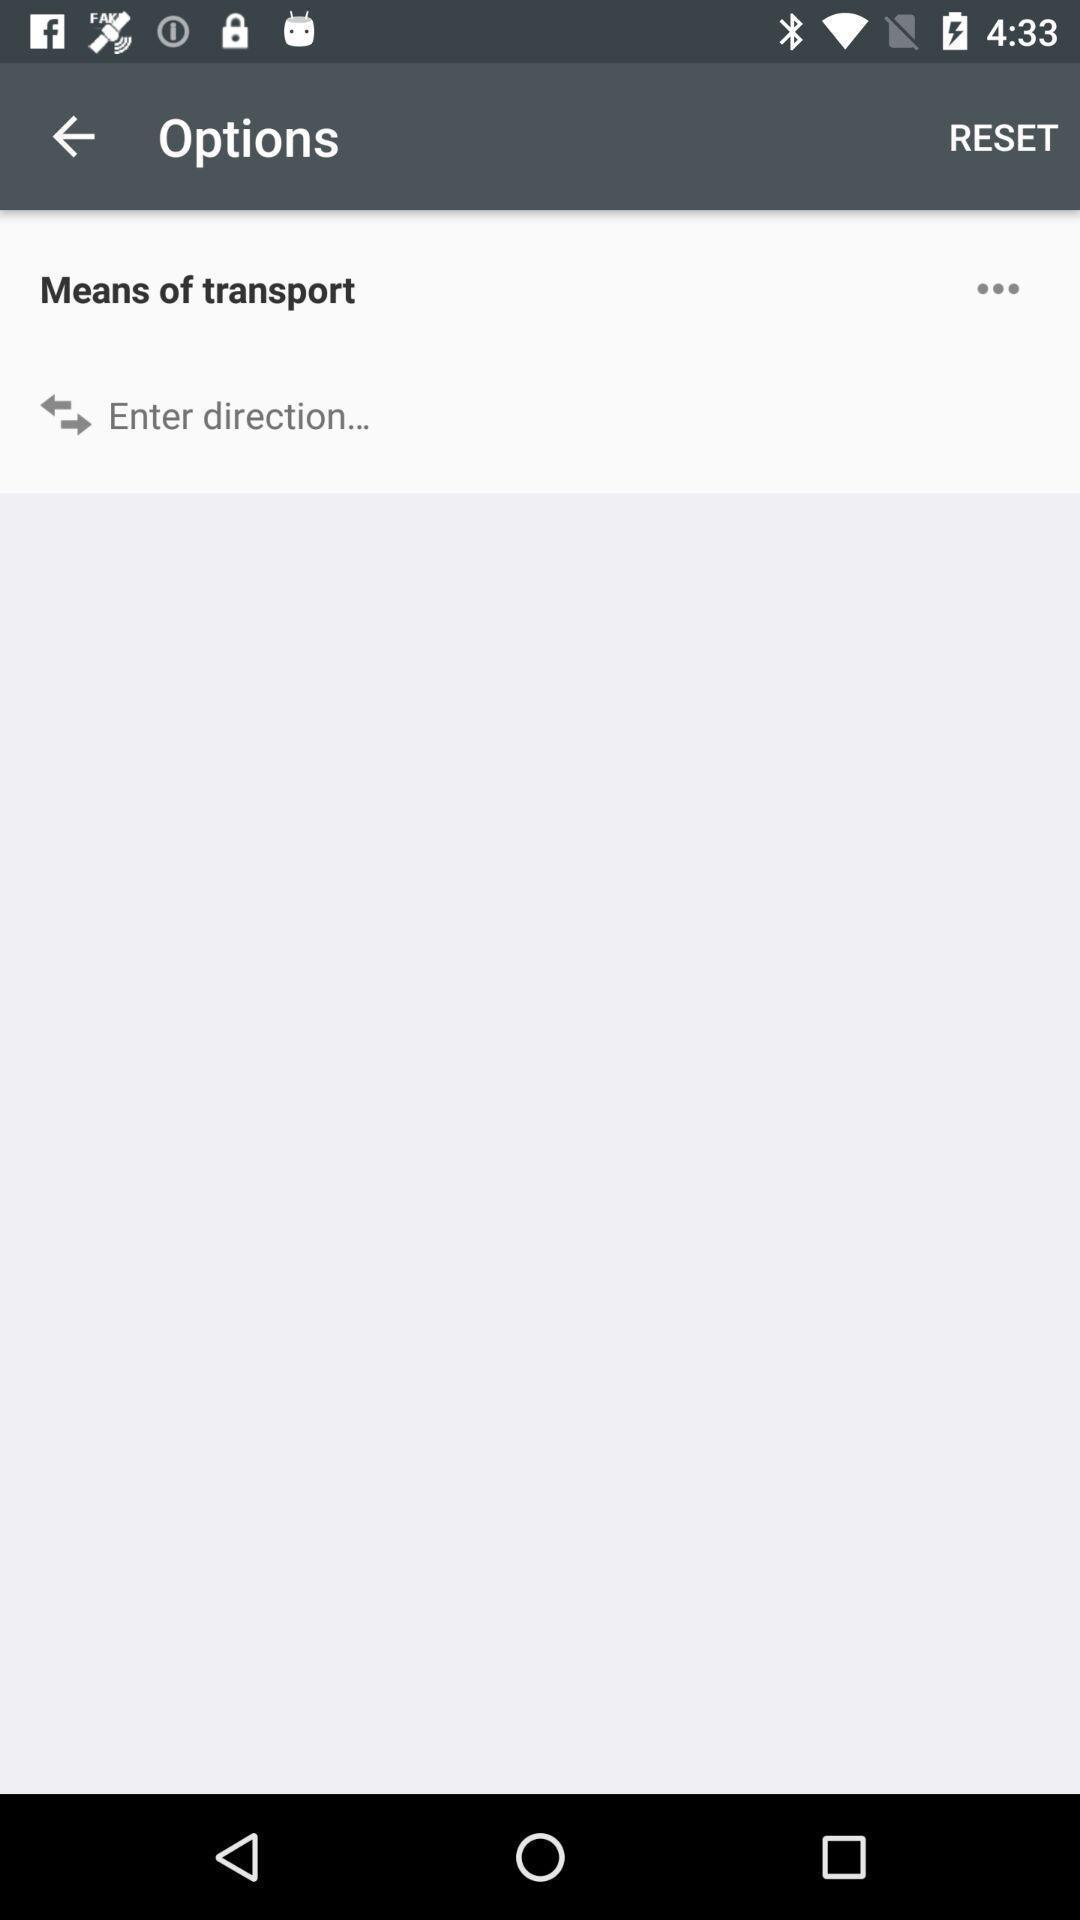Provide a textual representation of this image. Screen showing options page. 